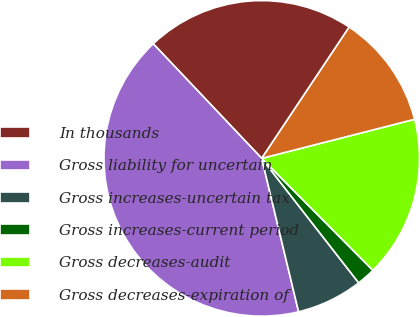<chart> <loc_0><loc_0><loc_500><loc_500><pie_chart><fcel>In thousands<fcel>Gross liability for uncertain<fcel>Gross increases-uncertain tax<fcel>Gross increases-current period<fcel>Gross decreases-audit<fcel>Gross decreases-expiration of<nl><fcel>21.42%<fcel>41.69%<fcel>6.78%<fcel>1.91%<fcel>16.54%<fcel>11.66%<nl></chart> 